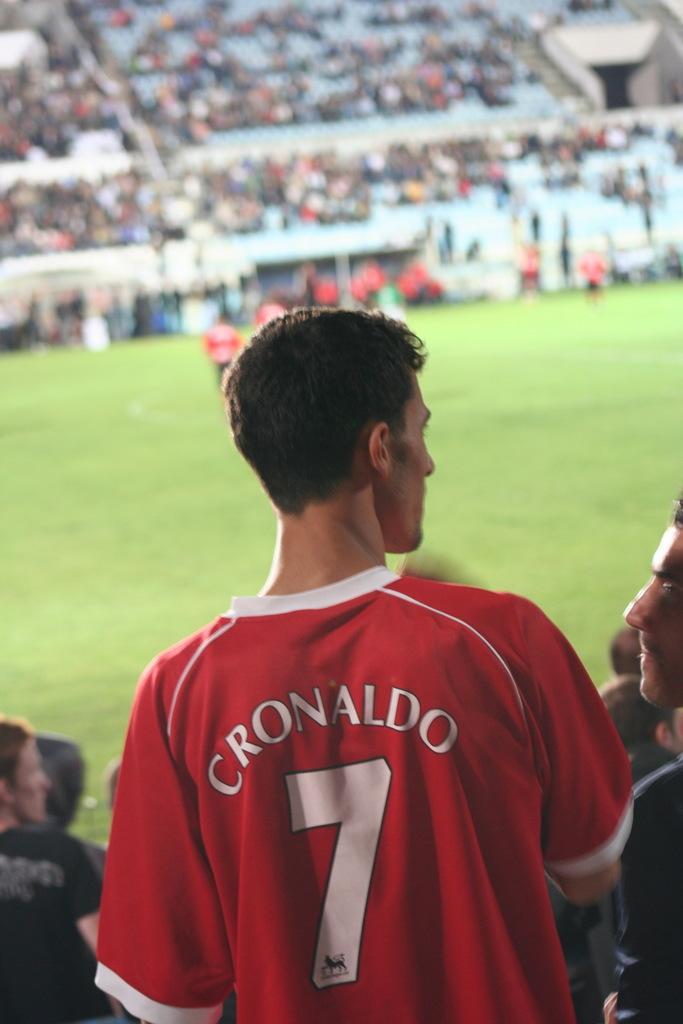<image>
Relay a brief, clear account of the picture shown. Player Cronaldo stands on the sidelines of a match. 